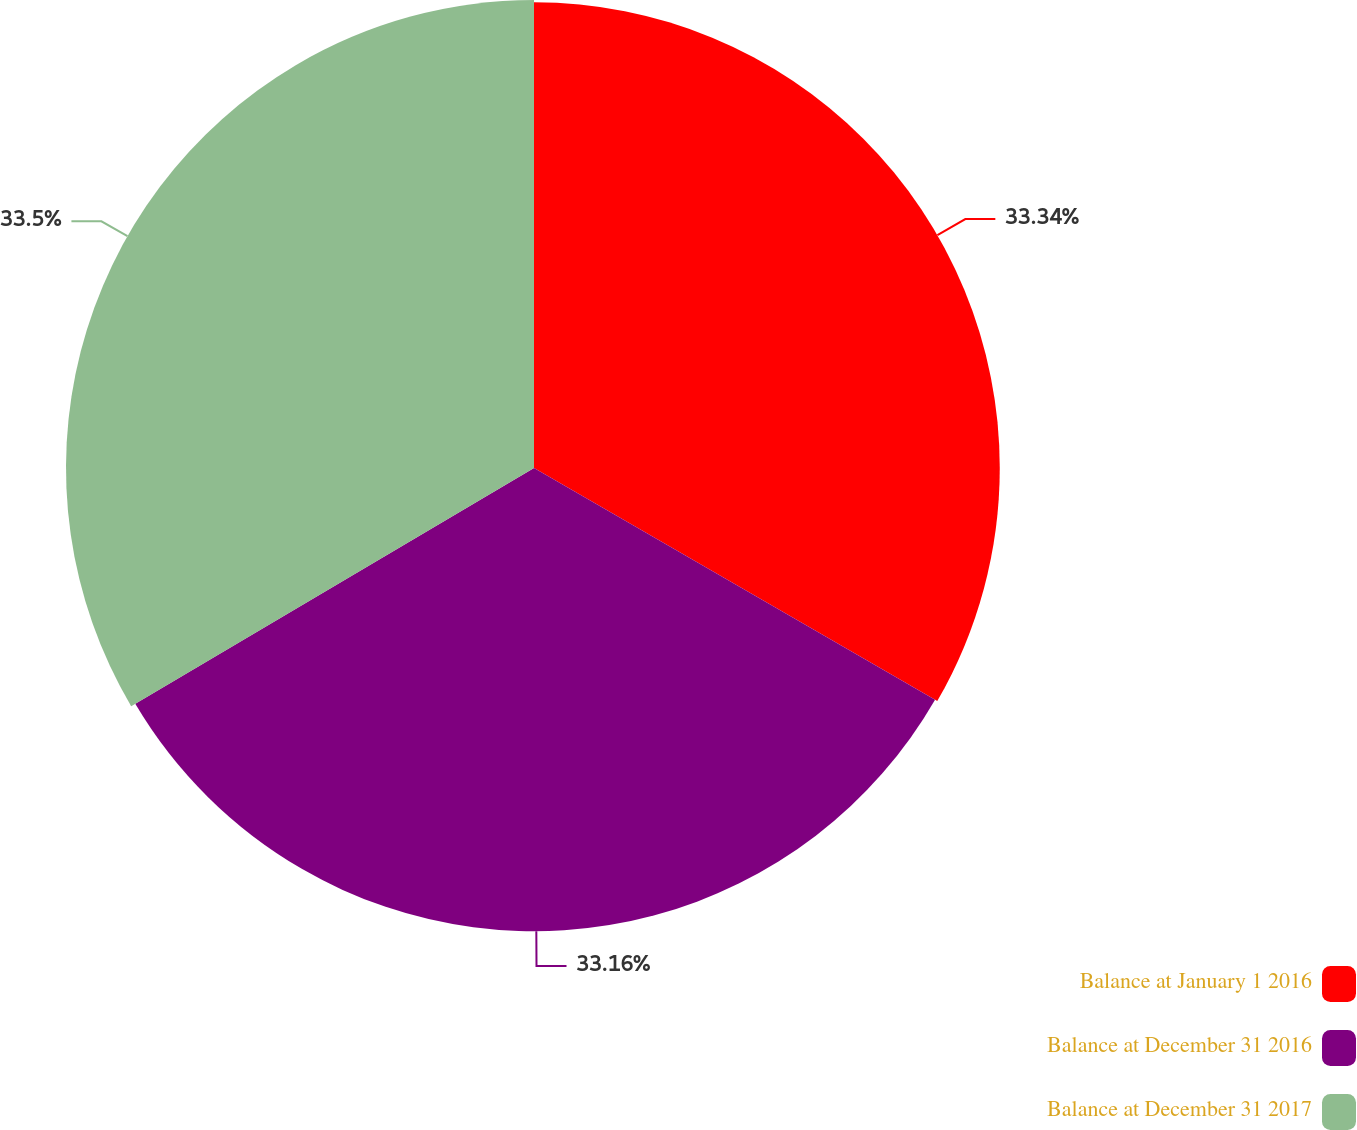Convert chart to OTSL. <chart><loc_0><loc_0><loc_500><loc_500><pie_chart><fcel>Balance at January 1 2016<fcel>Balance at December 31 2016<fcel>Balance at December 31 2017<nl><fcel>33.34%<fcel>33.16%<fcel>33.5%<nl></chart> 